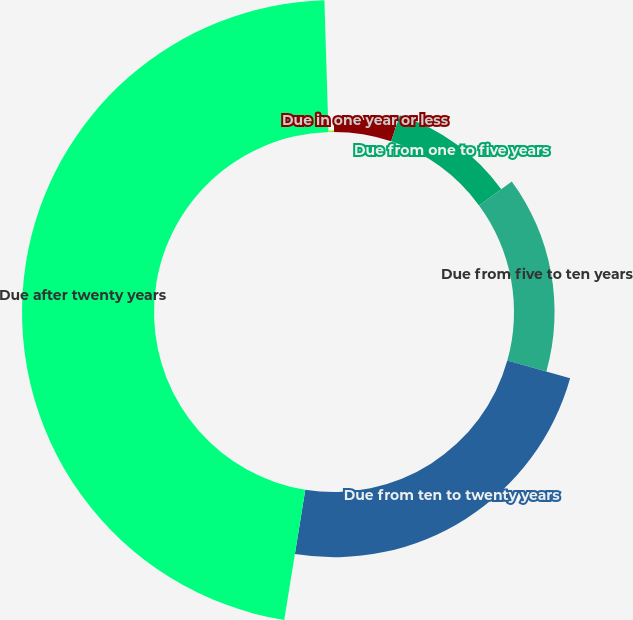Convert chart to OTSL. <chart><loc_0><loc_0><loc_500><loc_500><pie_chart><fcel>Due in one year or less<fcel>Due from one to five years<fcel>Due from five to ten years<fcel>Due from ten to twenty years<fcel>Due after twenty years<fcel>Mortgage-backed and<nl><fcel>5.14%<fcel>9.78%<fcel>14.43%<fcel>23.2%<fcel>46.96%<fcel>0.49%<nl></chart> 